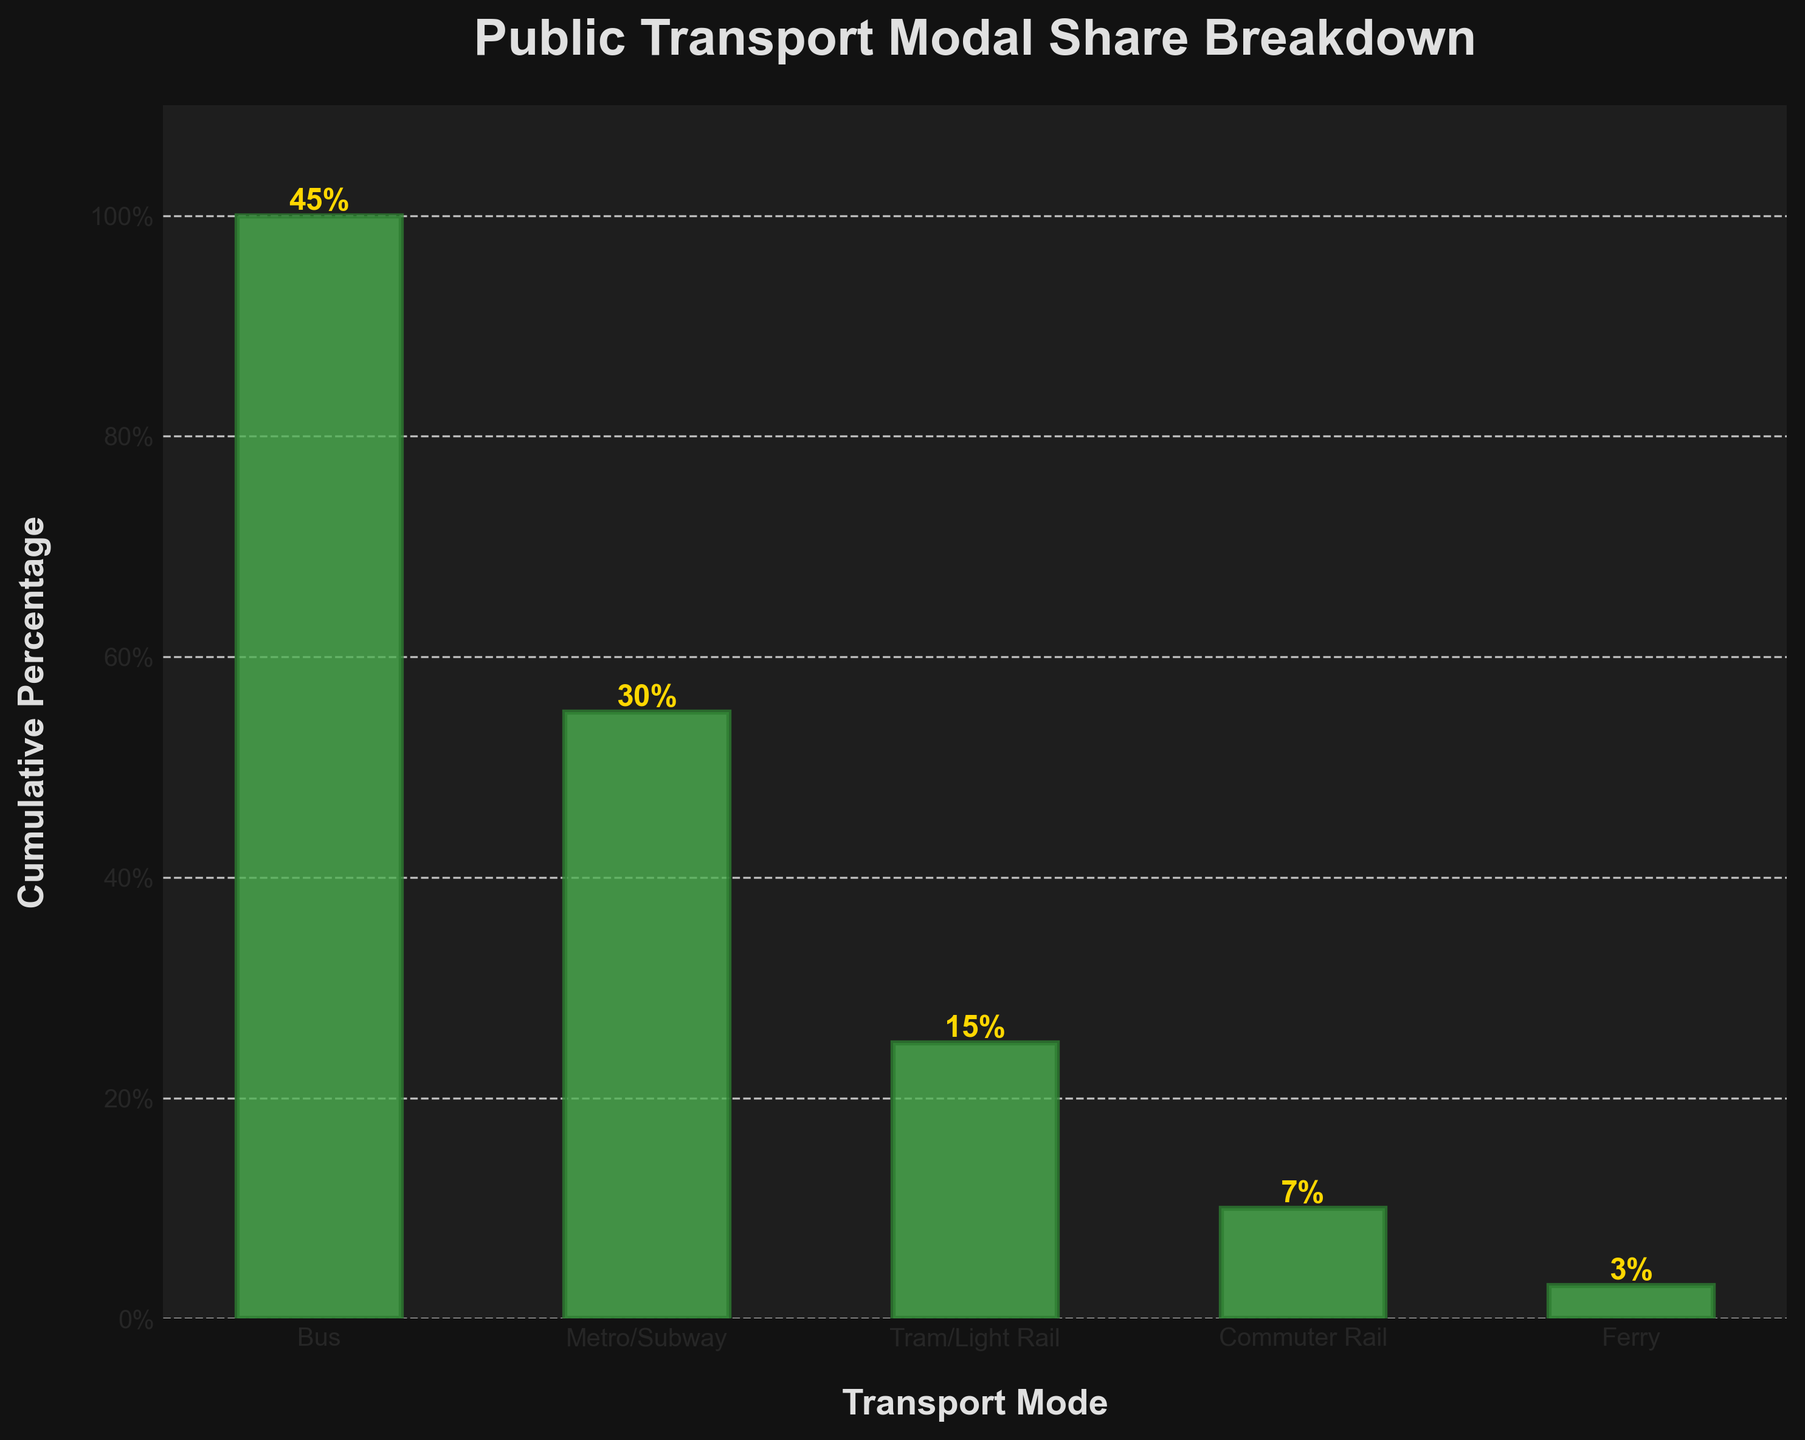What's the title of the funnel chart? The title of the chart is located at the top of the figure. It is usually displayed in larger and bold font.
Answer: Public Transport Modal Share Breakdown What mode of transport accounts for the smallest percentage? By looking at the heights of the bars, the smallest percentage will correspond to the shortest bar in the funnel.
Answer: Ferry What is the cumulative percentage for Metro/Subway? The cumulative percentage for each mode is shown by the heights of the bars. For Metro/Subway, find the corresponding bar.
Answer: 100% Which mode of transport has twice the percentage share of Tram/Light Rail? Tram/Light Rail has a share of 15%. The mode with twice this value (30%) must be identified from the percentages given for other modes.
Answer: Metro/Subway How much higher is the Bus percentage compared to Tram/Light Rail? Calculate the difference in percentage between Bus and Tram/Light Rail by subtracting the smaller percentage from the larger one (45 - 15).
Answer: 30% What is the total percentage for non-rail transports (Bus and Ferry)? Sum the percentages of the specified modes (Bus and Ferry). Bus is 45%, and Ferry is 3%. (45 + 3).
Answer: 48% Is the cumulative percentage for Commuter Rail less than 50%? Check the bar corresponding to Commuter Rail and read its cumulative percentage to determine if it's below 50%.
Answer: Yes Out of Tram/Light Rail and Commuter Rail, which has a higher percentage share? Compare the percentages of the two modes directly to see which one is larger. Tram/Light Rail is 15% and Commuter Rail is 7%.
Answer: Tram/Light Rail What is the sum of percentages for all rail-based transport modes? Add the percentages of Metro/Subway, Tram/Light Rail, and Commuter Rail (30 + 15 + 7).
Answer: 52% What is the average percentage share of the five transport modes? Calculate the average by summing all percentages (45 + 30 + 15 + 7 + 3) and then divide by the number of modes (5).
Answer: 20% 